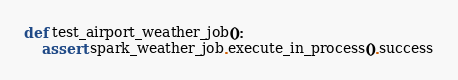<code> <loc_0><loc_0><loc_500><loc_500><_Python_>

def test_airport_weather_job():
    assert spark_weather_job.execute_in_process().success
</code> 